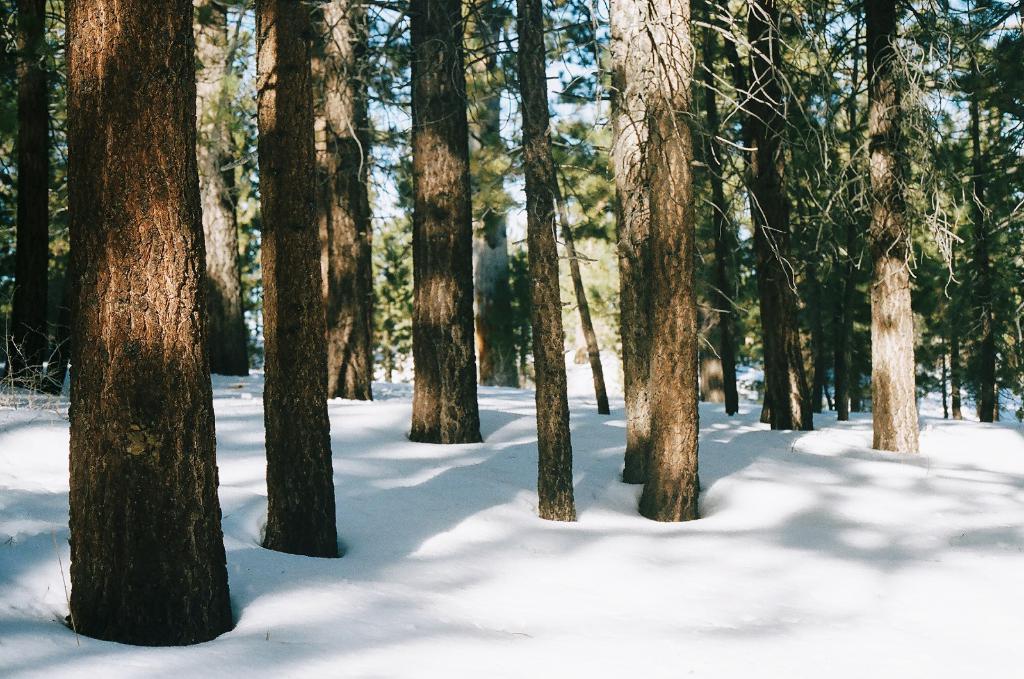Please provide a concise description of this image. In this image we can see sky, trees and snow. 